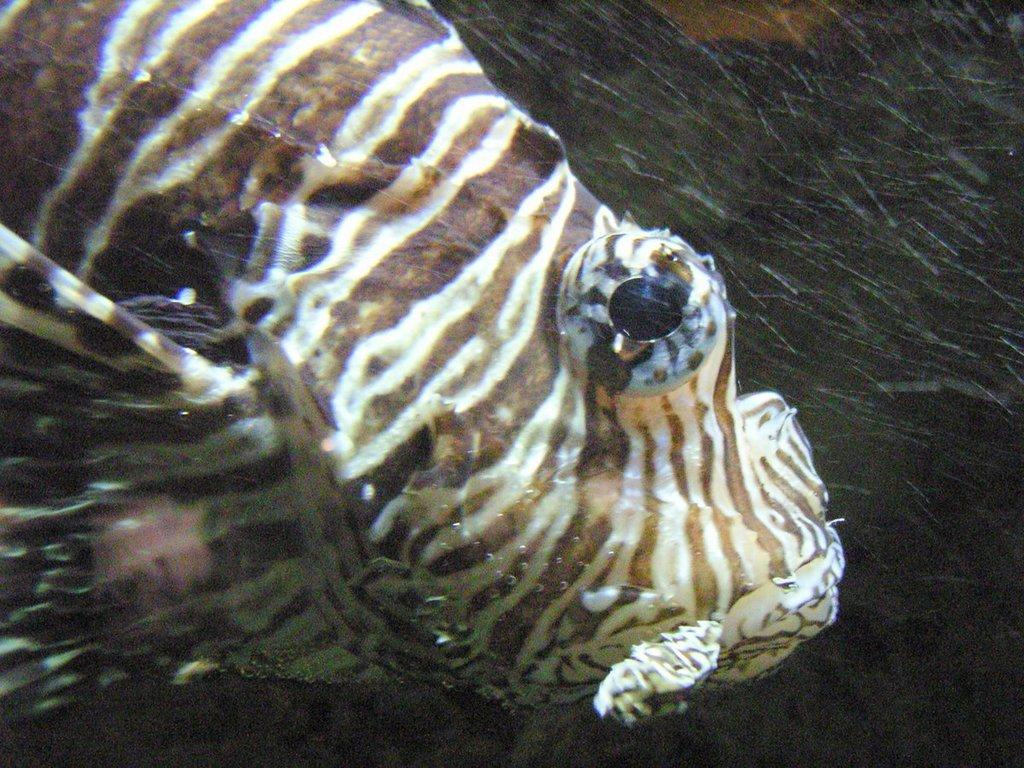What type of animal is in the image? There is a fish in the image. What is the primary element surrounding the fish? There is water visible in the image. What type of apparatus is being used to measure the fish's minute movements in the image? There is no apparatus or measurement of the fish's movements in the image; it simply shows a fish in water. 